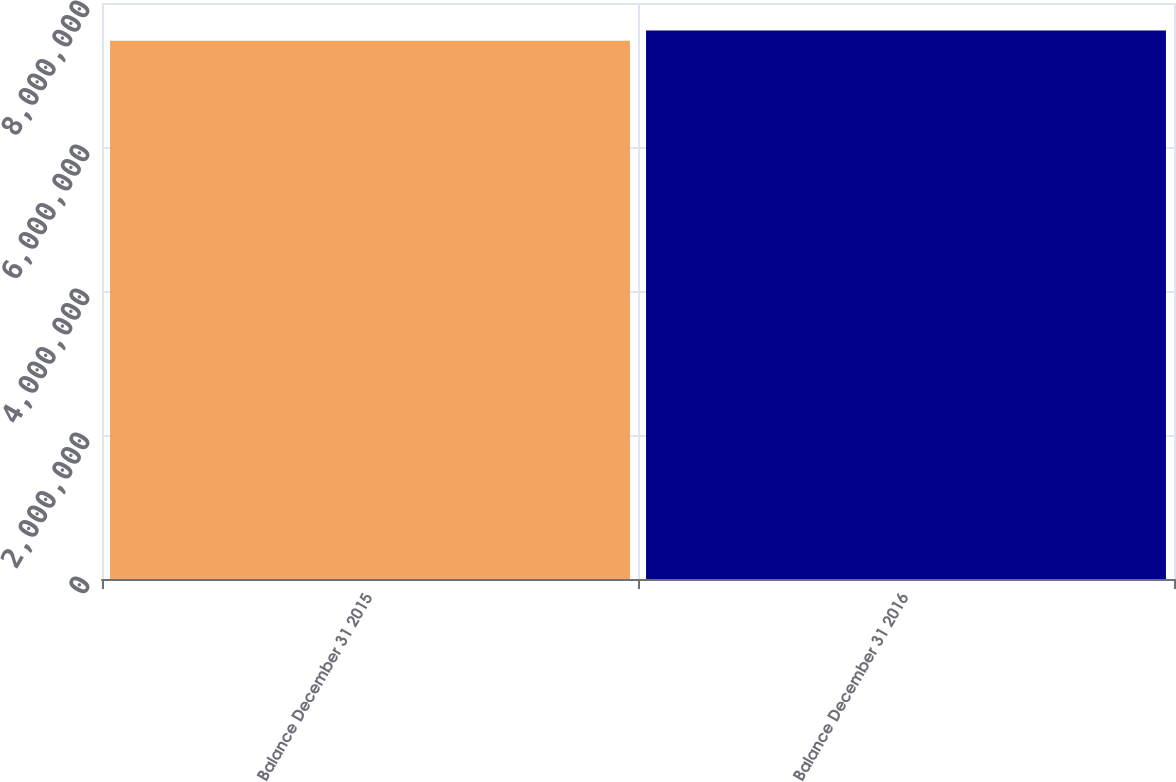Convert chart to OTSL. <chart><loc_0><loc_0><loc_500><loc_500><bar_chart><fcel>Balance December 31 2015<fcel>Balance December 31 2016<nl><fcel>7.47608e+06<fcel>7.6185e+06<nl></chart> 